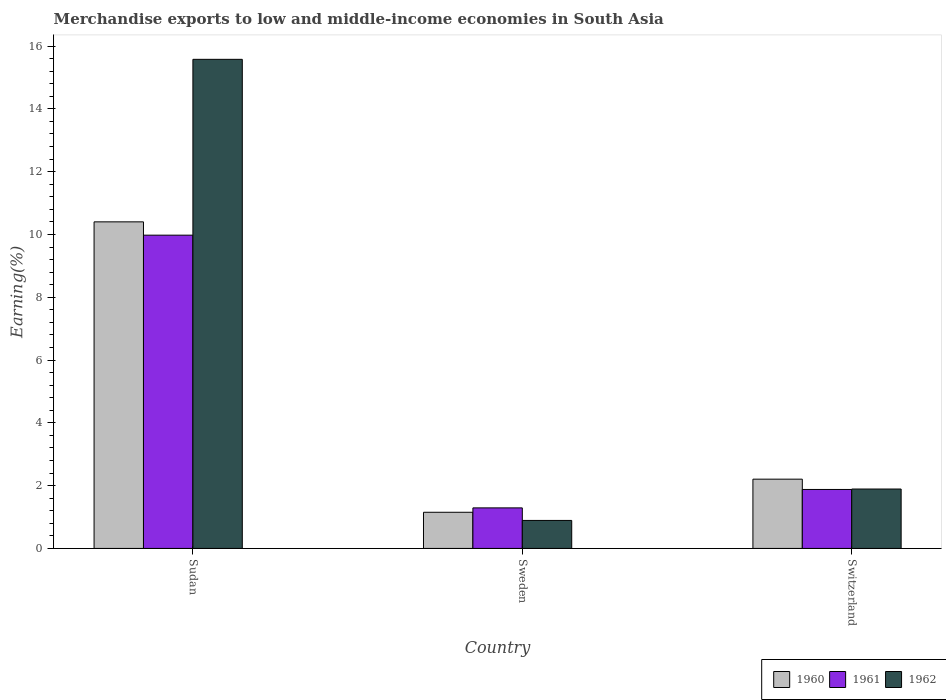How many different coloured bars are there?
Your answer should be compact. 3. Are the number of bars per tick equal to the number of legend labels?
Offer a terse response. Yes. Are the number of bars on each tick of the X-axis equal?
Your response must be concise. Yes. How many bars are there on the 2nd tick from the left?
Give a very brief answer. 3. How many bars are there on the 2nd tick from the right?
Provide a succinct answer. 3. What is the percentage of amount earned from merchandise exports in 1960 in Sudan?
Make the answer very short. 10.4. Across all countries, what is the maximum percentage of amount earned from merchandise exports in 1962?
Your response must be concise. 15.58. Across all countries, what is the minimum percentage of amount earned from merchandise exports in 1962?
Keep it short and to the point. 0.89. In which country was the percentage of amount earned from merchandise exports in 1961 maximum?
Ensure brevity in your answer.  Sudan. In which country was the percentage of amount earned from merchandise exports in 1961 minimum?
Offer a very short reply. Sweden. What is the total percentage of amount earned from merchandise exports in 1961 in the graph?
Your response must be concise. 13.15. What is the difference between the percentage of amount earned from merchandise exports in 1961 in Sudan and that in Sweden?
Give a very brief answer. 8.69. What is the difference between the percentage of amount earned from merchandise exports in 1962 in Sweden and the percentage of amount earned from merchandise exports in 1960 in Sudan?
Keep it short and to the point. -9.51. What is the average percentage of amount earned from merchandise exports in 1962 per country?
Provide a short and direct response. 6.12. What is the difference between the percentage of amount earned from merchandise exports of/in 1961 and percentage of amount earned from merchandise exports of/in 1962 in Sweden?
Offer a terse response. 0.4. In how many countries, is the percentage of amount earned from merchandise exports in 1960 greater than 1.2000000000000002 %?
Offer a very short reply. 2. What is the ratio of the percentage of amount earned from merchandise exports in 1960 in Sudan to that in Switzerland?
Ensure brevity in your answer.  4.71. Is the percentage of amount earned from merchandise exports in 1962 in Sudan less than that in Switzerland?
Offer a terse response. No. Is the difference between the percentage of amount earned from merchandise exports in 1961 in Sudan and Switzerland greater than the difference between the percentage of amount earned from merchandise exports in 1962 in Sudan and Switzerland?
Offer a very short reply. No. What is the difference between the highest and the second highest percentage of amount earned from merchandise exports in 1960?
Give a very brief answer. -9.25. What is the difference between the highest and the lowest percentage of amount earned from merchandise exports in 1960?
Offer a very short reply. 9.25. In how many countries, is the percentage of amount earned from merchandise exports in 1962 greater than the average percentage of amount earned from merchandise exports in 1962 taken over all countries?
Your answer should be compact. 1. Is the sum of the percentage of amount earned from merchandise exports in 1961 in Sweden and Switzerland greater than the maximum percentage of amount earned from merchandise exports in 1962 across all countries?
Make the answer very short. No. What does the 3rd bar from the left in Sweden represents?
Your answer should be very brief. 1962. What does the 3rd bar from the right in Sweden represents?
Offer a terse response. 1960. Is it the case that in every country, the sum of the percentage of amount earned from merchandise exports in 1960 and percentage of amount earned from merchandise exports in 1961 is greater than the percentage of amount earned from merchandise exports in 1962?
Your response must be concise. Yes. Does the graph contain any zero values?
Ensure brevity in your answer.  No. Does the graph contain grids?
Your answer should be very brief. No. Where does the legend appear in the graph?
Your answer should be very brief. Bottom right. How many legend labels are there?
Keep it short and to the point. 3. What is the title of the graph?
Offer a terse response. Merchandise exports to low and middle-income economies in South Asia. Does "1984" appear as one of the legend labels in the graph?
Make the answer very short. No. What is the label or title of the Y-axis?
Ensure brevity in your answer.  Earning(%). What is the Earning(%) in 1960 in Sudan?
Keep it short and to the point. 10.4. What is the Earning(%) in 1961 in Sudan?
Provide a short and direct response. 9.98. What is the Earning(%) in 1962 in Sudan?
Your response must be concise. 15.58. What is the Earning(%) in 1960 in Sweden?
Keep it short and to the point. 1.15. What is the Earning(%) in 1961 in Sweden?
Ensure brevity in your answer.  1.29. What is the Earning(%) in 1962 in Sweden?
Your answer should be compact. 0.89. What is the Earning(%) of 1960 in Switzerland?
Offer a very short reply. 2.21. What is the Earning(%) in 1961 in Switzerland?
Keep it short and to the point. 1.88. What is the Earning(%) of 1962 in Switzerland?
Your answer should be compact. 1.89. Across all countries, what is the maximum Earning(%) of 1960?
Keep it short and to the point. 10.4. Across all countries, what is the maximum Earning(%) of 1961?
Your answer should be very brief. 9.98. Across all countries, what is the maximum Earning(%) in 1962?
Provide a short and direct response. 15.58. Across all countries, what is the minimum Earning(%) in 1960?
Your answer should be very brief. 1.15. Across all countries, what is the minimum Earning(%) of 1961?
Your response must be concise. 1.29. Across all countries, what is the minimum Earning(%) of 1962?
Your response must be concise. 0.89. What is the total Earning(%) of 1960 in the graph?
Give a very brief answer. 13.76. What is the total Earning(%) in 1961 in the graph?
Provide a succinct answer. 13.15. What is the total Earning(%) in 1962 in the graph?
Keep it short and to the point. 18.36. What is the difference between the Earning(%) in 1960 in Sudan and that in Sweden?
Keep it short and to the point. 9.25. What is the difference between the Earning(%) in 1961 in Sudan and that in Sweden?
Provide a short and direct response. 8.69. What is the difference between the Earning(%) of 1962 in Sudan and that in Sweden?
Your response must be concise. 14.69. What is the difference between the Earning(%) of 1960 in Sudan and that in Switzerland?
Your answer should be very brief. 8.2. What is the difference between the Earning(%) of 1961 in Sudan and that in Switzerland?
Your answer should be compact. 8.1. What is the difference between the Earning(%) in 1962 in Sudan and that in Switzerland?
Offer a very short reply. 13.69. What is the difference between the Earning(%) in 1960 in Sweden and that in Switzerland?
Your answer should be compact. -1.05. What is the difference between the Earning(%) of 1961 in Sweden and that in Switzerland?
Keep it short and to the point. -0.59. What is the difference between the Earning(%) of 1962 in Sweden and that in Switzerland?
Your answer should be very brief. -1. What is the difference between the Earning(%) of 1960 in Sudan and the Earning(%) of 1961 in Sweden?
Provide a succinct answer. 9.11. What is the difference between the Earning(%) in 1960 in Sudan and the Earning(%) in 1962 in Sweden?
Offer a very short reply. 9.51. What is the difference between the Earning(%) of 1961 in Sudan and the Earning(%) of 1962 in Sweden?
Ensure brevity in your answer.  9.09. What is the difference between the Earning(%) in 1960 in Sudan and the Earning(%) in 1961 in Switzerland?
Your answer should be very brief. 8.52. What is the difference between the Earning(%) in 1960 in Sudan and the Earning(%) in 1962 in Switzerland?
Your answer should be very brief. 8.51. What is the difference between the Earning(%) of 1961 in Sudan and the Earning(%) of 1962 in Switzerland?
Keep it short and to the point. 8.09. What is the difference between the Earning(%) in 1960 in Sweden and the Earning(%) in 1961 in Switzerland?
Your answer should be compact. -0.73. What is the difference between the Earning(%) of 1960 in Sweden and the Earning(%) of 1962 in Switzerland?
Your answer should be very brief. -0.74. What is the difference between the Earning(%) of 1961 in Sweden and the Earning(%) of 1962 in Switzerland?
Keep it short and to the point. -0.6. What is the average Earning(%) of 1960 per country?
Offer a very short reply. 4.59. What is the average Earning(%) of 1961 per country?
Your response must be concise. 4.38. What is the average Earning(%) of 1962 per country?
Give a very brief answer. 6.12. What is the difference between the Earning(%) in 1960 and Earning(%) in 1961 in Sudan?
Keep it short and to the point. 0.42. What is the difference between the Earning(%) of 1960 and Earning(%) of 1962 in Sudan?
Provide a short and direct response. -5.18. What is the difference between the Earning(%) in 1961 and Earning(%) in 1962 in Sudan?
Make the answer very short. -5.6. What is the difference between the Earning(%) of 1960 and Earning(%) of 1961 in Sweden?
Your answer should be compact. -0.14. What is the difference between the Earning(%) of 1960 and Earning(%) of 1962 in Sweden?
Keep it short and to the point. 0.26. What is the difference between the Earning(%) in 1961 and Earning(%) in 1962 in Sweden?
Provide a short and direct response. 0.4. What is the difference between the Earning(%) of 1960 and Earning(%) of 1961 in Switzerland?
Keep it short and to the point. 0.33. What is the difference between the Earning(%) of 1960 and Earning(%) of 1962 in Switzerland?
Your response must be concise. 0.31. What is the difference between the Earning(%) in 1961 and Earning(%) in 1962 in Switzerland?
Provide a short and direct response. -0.01. What is the ratio of the Earning(%) in 1960 in Sudan to that in Sweden?
Keep it short and to the point. 9.03. What is the ratio of the Earning(%) in 1961 in Sudan to that in Sweden?
Make the answer very short. 7.73. What is the ratio of the Earning(%) in 1962 in Sudan to that in Sweden?
Your answer should be very brief. 17.47. What is the ratio of the Earning(%) in 1960 in Sudan to that in Switzerland?
Keep it short and to the point. 4.71. What is the ratio of the Earning(%) of 1961 in Sudan to that in Switzerland?
Offer a very short reply. 5.31. What is the ratio of the Earning(%) of 1962 in Sudan to that in Switzerland?
Give a very brief answer. 8.23. What is the ratio of the Earning(%) in 1960 in Sweden to that in Switzerland?
Your answer should be compact. 0.52. What is the ratio of the Earning(%) of 1961 in Sweden to that in Switzerland?
Make the answer very short. 0.69. What is the ratio of the Earning(%) of 1962 in Sweden to that in Switzerland?
Your response must be concise. 0.47. What is the difference between the highest and the second highest Earning(%) of 1960?
Provide a short and direct response. 8.2. What is the difference between the highest and the second highest Earning(%) of 1961?
Your answer should be compact. 8.1. What is the difference between the highest and the second highest Earning(%) in 1962?
Give a very brief answer. 13.69. What is the difference between the highest and the lowest Earning(%) of 1960?
Your answer should be very brief. 9.25. What is the difference between the highest and the lowest Earning(%) in 1961?
Keep it short and to the point. 8.69. What is the difference between the highest and the lowest Earning(%) of 1962?
Ensure brevity in your answer.  14.69. 